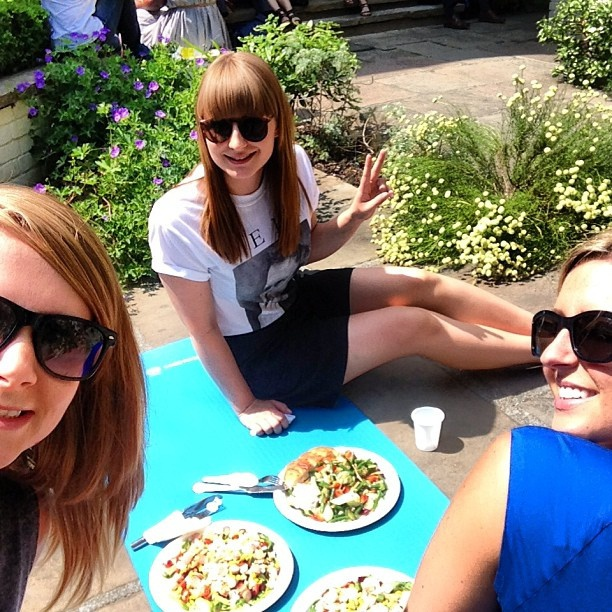Describe the objects in this image and their specific colors. I can see people in lightgreen, black, brown, maroon, and white tones, people in lightgreen, black, maroon, brown, and tan tones, people in lightgreen, blue, tan, darkblue, and beige tones, people in lightgreen, black, lightblue, darkgreen, and navy tones, and people in lightgreen, darkgray, gray, white, and black tones in this image. 